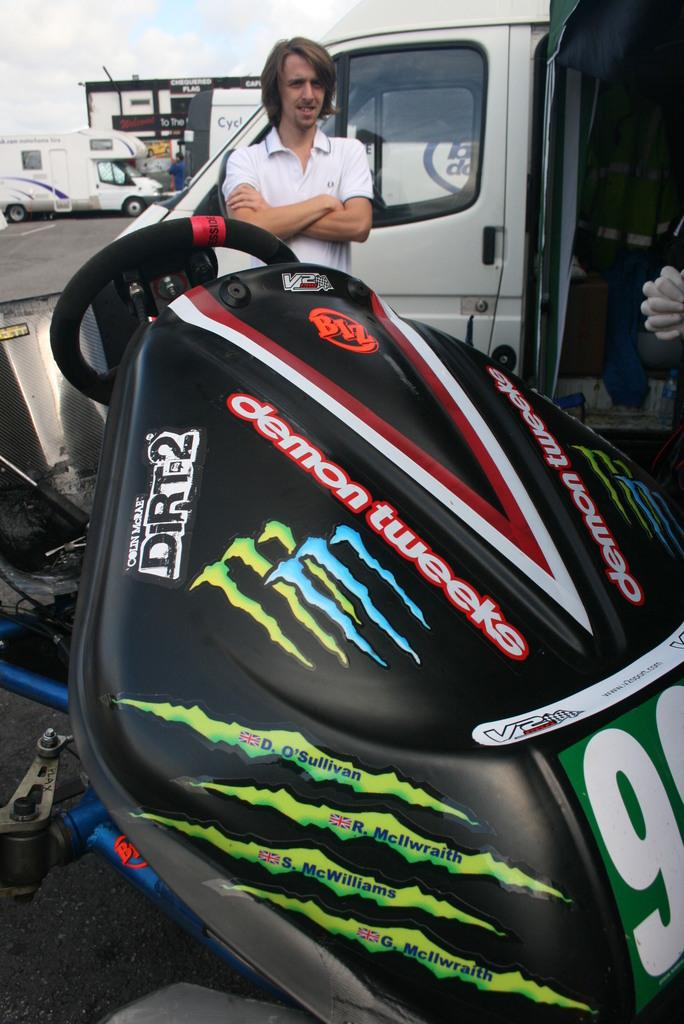Who is the main subject in the image? There is a man in the image. What else can be seen in the image besides the man? There are vehicles in the image. What is visible in the background of the image? The sky is visible in the background of the image. Can you describe the sky in the image? Clouds are present in the sky. What type of ant can be seen claiming its territory in the image? There are no ants present in the image, and therefore no territory is being claimed by an ant. 